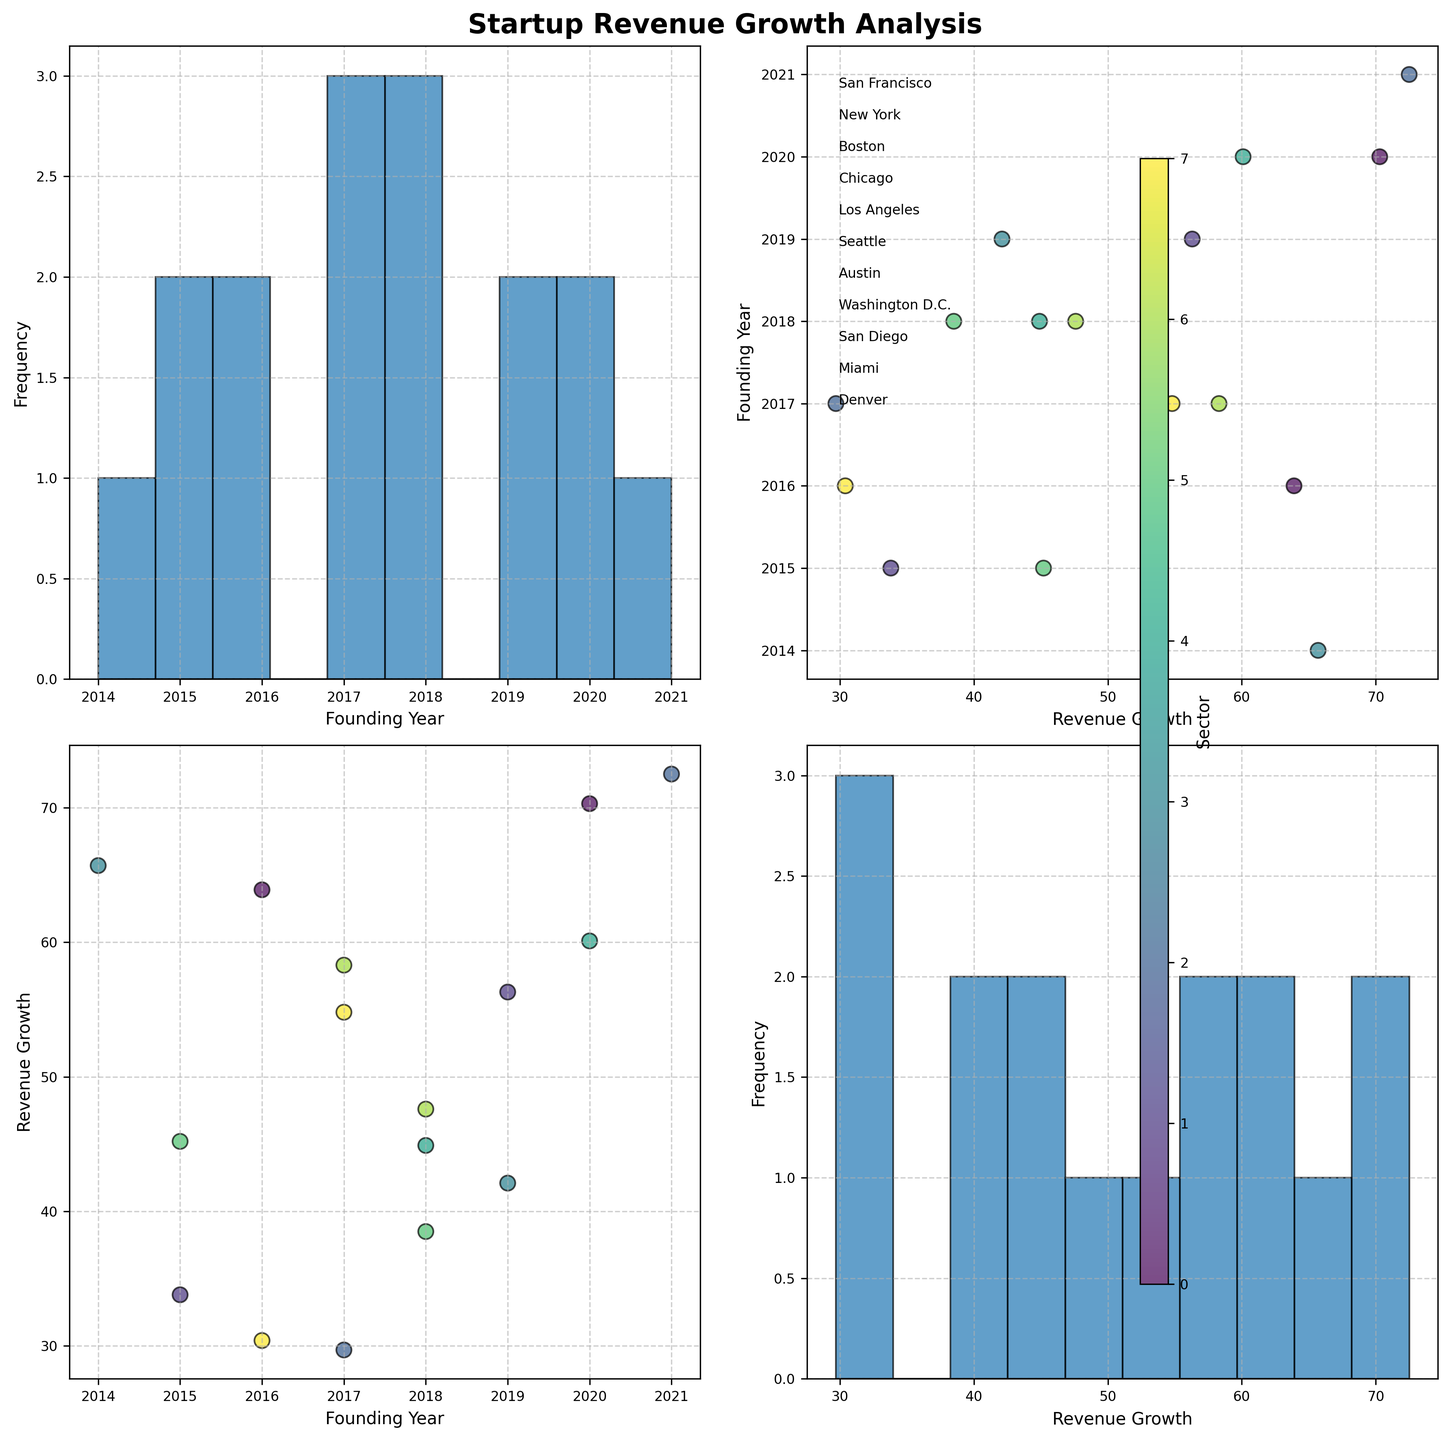What's the title of the figure? The title is located at the top of the figure, and it reads "Startup Revenue Growth Analysis".
Answer: Startup Revenue Growth Analysis What are the labels on the x-axis and y-axis in the histogram? In the histogram, the x-axis is labeled as "Founding Year" and the y-axis is labeled as "Frequency", indicating the number of startups founded in each bin.
Answer: Founding Year, Frequency Which locations are annotated in the scatter plot matrix? In the scatter plot matrix, the locations are annotated at the top right of the figure (sub-plot axes[0,1]). The locations annotated are "San Francisco", "New York", "Boston", "Chicago", "Los Angeles", "Seattle", "Austin", "Washington D.C.", "San Diego", "Miami", and "Denver".
Answer: San Francisco, New York, Boston, Chicago, Los Angeles, Seattle, Austin, Washington D.C., San Diego, Miami, Denver Which sector has the highest "Revenue Growth" and what is the value? Observing the scatter plots and looking at the color gradient representing different sectors, the highest revenue growth point (72.5) is associated with the cybersecurity sector which can be inferred from the color scheme and legend alignment.
Answer: Cybersecurity, 72.5 How does "Revenue Growth" compare between startups founded in 2016 and 2018? From the scatter plot between "Founding Year" and "Revenue Growth", we compare points for 2016 and 2018 and observe their positions vertically. The 2016 startups have revenue growth values around 30.4, 33.8, 63.9, while 2018 startups have values around 38.5, 44.9, 47.6. The former has a wider range with higher peaks.
Answer: Startups from 2016 have a higher peak What's the average "Revenue Growth" for E-commerce startups? From the scatter plots, identify data points corresponding to E-commerce startups and their revenue growth values: 65.7, 42.1. Calculate the average: (65.7 + 42.1) / 2 = 53.9
Answer: 53.9 Which startup has the earliest founding year, and what is its "Revenue Growth"? From the scatter plot, locate the minimum founding year and check the corresponding data point. The earliest founding year is 2014 (E-commerce, Los Angeles), with a revenue growth of 65.7.
Answer: 2014, 65.7 Is there a trend visible between the founding year and "Revenue Growth"? Looking at the scatter plot between "Founding Year" and "Revenue Growth", you can observe the overall distribution and trend. In general, there is no clear linear trend, but some scattered higher growths in recent years.
Answer: No clear trend Which location has the highest density of startups based on the histograms and scatter plots? Analyze the histograms and scatter plots to see the highest frequencies and distributions. San Francisco has multiple entries in the histograms and scatter plots indicating it might have the highest density.
Answer: San Francisco 